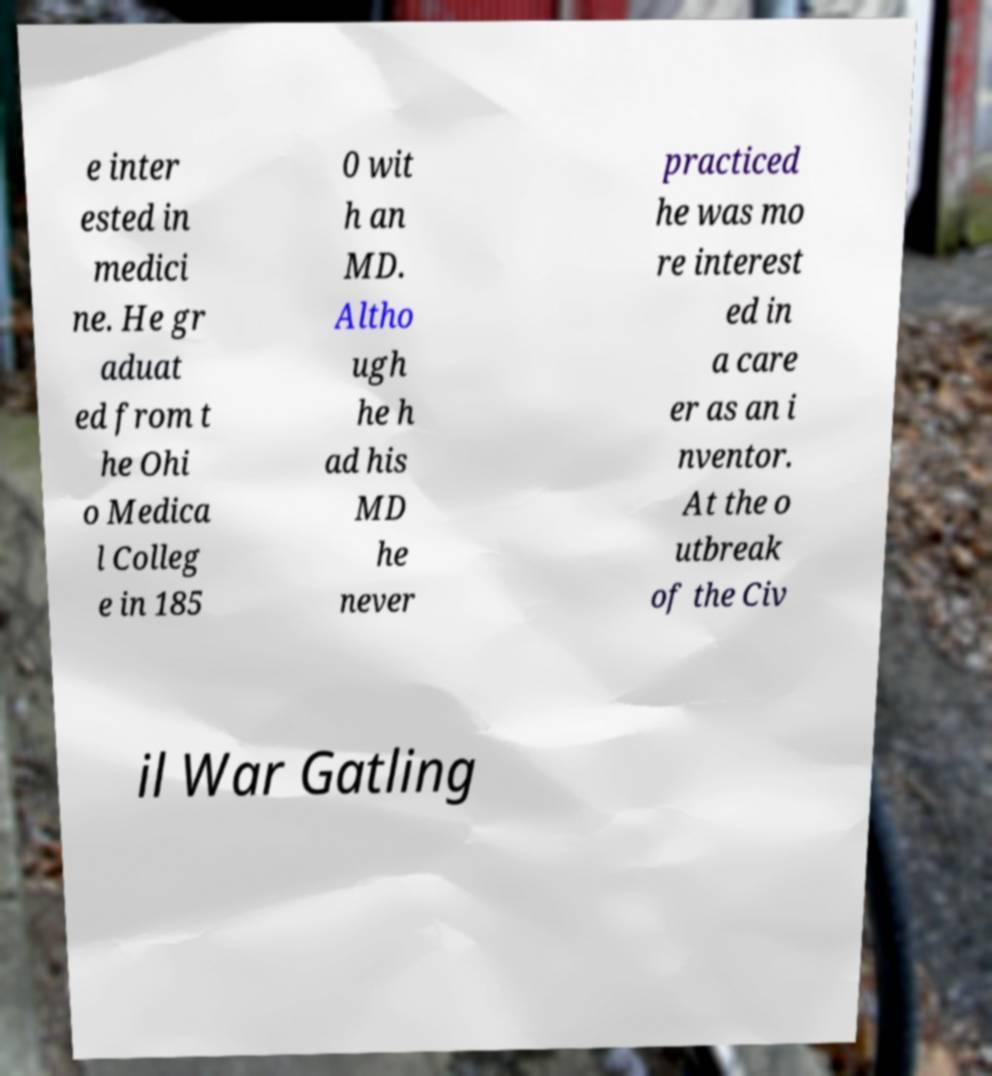Can you read and provide the text displayed in the image?This photo seems to have some interesting text. Can you extract and type it out for me? e inter ested in medici ne. He gr aduat ed from t he Ohi o Medica l Colleg e in 185 0 wit h an MD. Altho ugh he h ad his MD he never practiced he was mo re interest ed in a care er as an i nventor. At the o utbreak of the Civ il War Gatling 